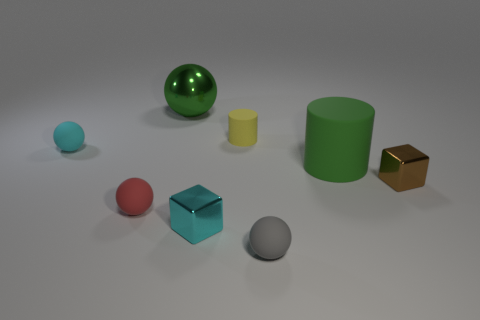Add 2 yellow rubber cylinders. How many objects exist? 10 Subtract all cylinders. How many objects are left? 6 Add 1 tiny yellow things. How many tiny yellow things are left? 2 Add 5 small red shiny balls. How many small red shiny balls exist? 5 Subtract 0 yellow balls. How many objects are left? 8 Subtract all tiny red rubber things. Subtract all shiny cubes. How many objects are left? 5 